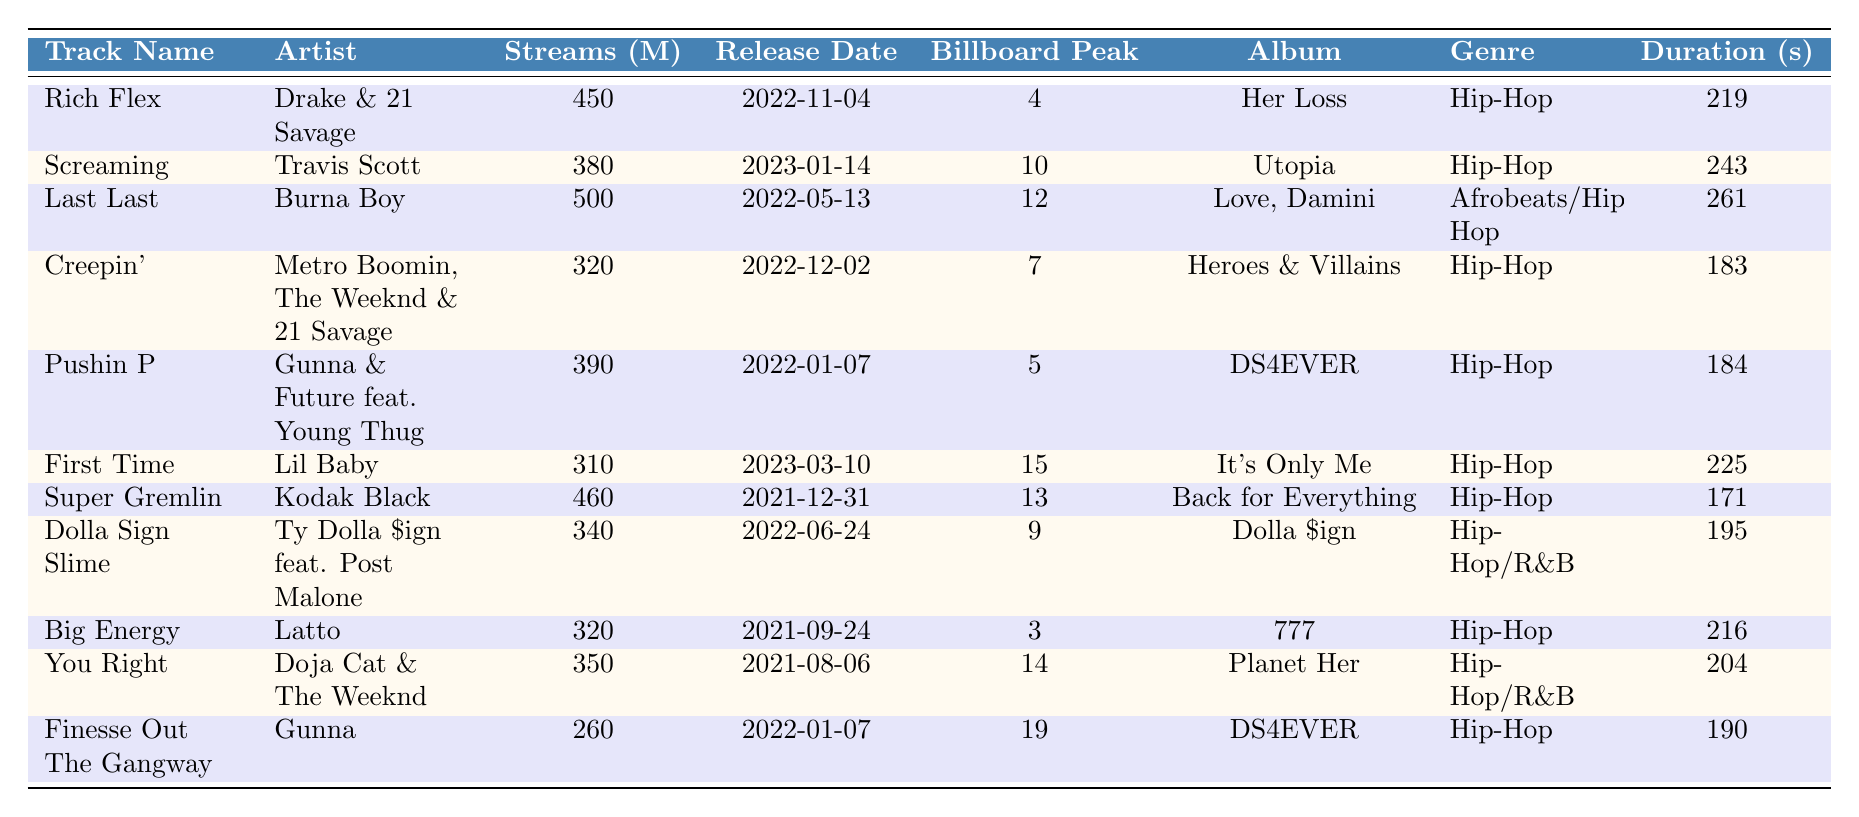What is the track with the highest number of streams? By scanning through the "Streams (M)" column of the table, it's clear that "Last Last" by Burna Boy has the most streams at 500 million.
Answer: Last Last Which artist has the least popular track based on Billboard chart peak? Looking at the "Billboard Peak" column, "Finesse Out The Gangway" by Gunna has the lowest peak at 19.
Answer: Finesse Out The Gangway How many tracks were released in 2023? From the "Release Date" column, only "Screaming" and "First Time" have release dates in 2023, indicating a total of 2 tracks.
Answer: 2 What is the average duration of the tracks listed? To find the average duration, add all durations (219 + 243 + 261 + 183 + 184 + 225 + 171 + 195 + 216 + 204 + 190 =  2428 seconds) and divide by the number of tracks (11), resulting in an average of roughly 220.73 seconds.
Answer: 220.73 seconds Does "Rich Flex" have a higher stream count than "Creepin'"? Comparing the stream counts, "Rich Flex" has 450 million streams, while "Creepin'" has 320 million, which confirms that "Rich Flex" indeed has a higher stream count.
Answer: Yes What is the total number of streams for all the tracks listed? Adding all the streams together (450 + 380 + 500 + 320 + 390 + 310 + 460 + 340 + 320 + 350 + 260 =  4180 million), the total number of streams for all tracks is 4180 million.
Answer: 4180 million Which genre has the most tracks listed in the table? Upon review, there are 8 tracks classified strictly as "Hip-Hop" and 3 that fit into "Hip-Hop/R&B" or "Afrobeats/Hip-Hop," indicating that "Hip-Hop" is represented the most in the table.
Answer: Hip-Hop Is the album "DS4EVER" related to the track with the longest duration? The longest track is "Last Last" (261 seconds), which is not from "DS4EVER" but instead from "Love, Damini," confirming that these do not correlate in this case.
Answer: No What is the difference in streams between "Super Gremlin" and "First Time"? "Super Gremlin" has 460 million streams and "First Time" has 310 million. The difference is calculated as 460 - 310 = 150 million streams.
Answer: 150 million streams Which artist has multiple tracks in the table? By examining the artists, both Gunna and 21 Savage appear more than once, thus confirming multiple contributions to the list.
Answer: Gunna and 21 Savage 